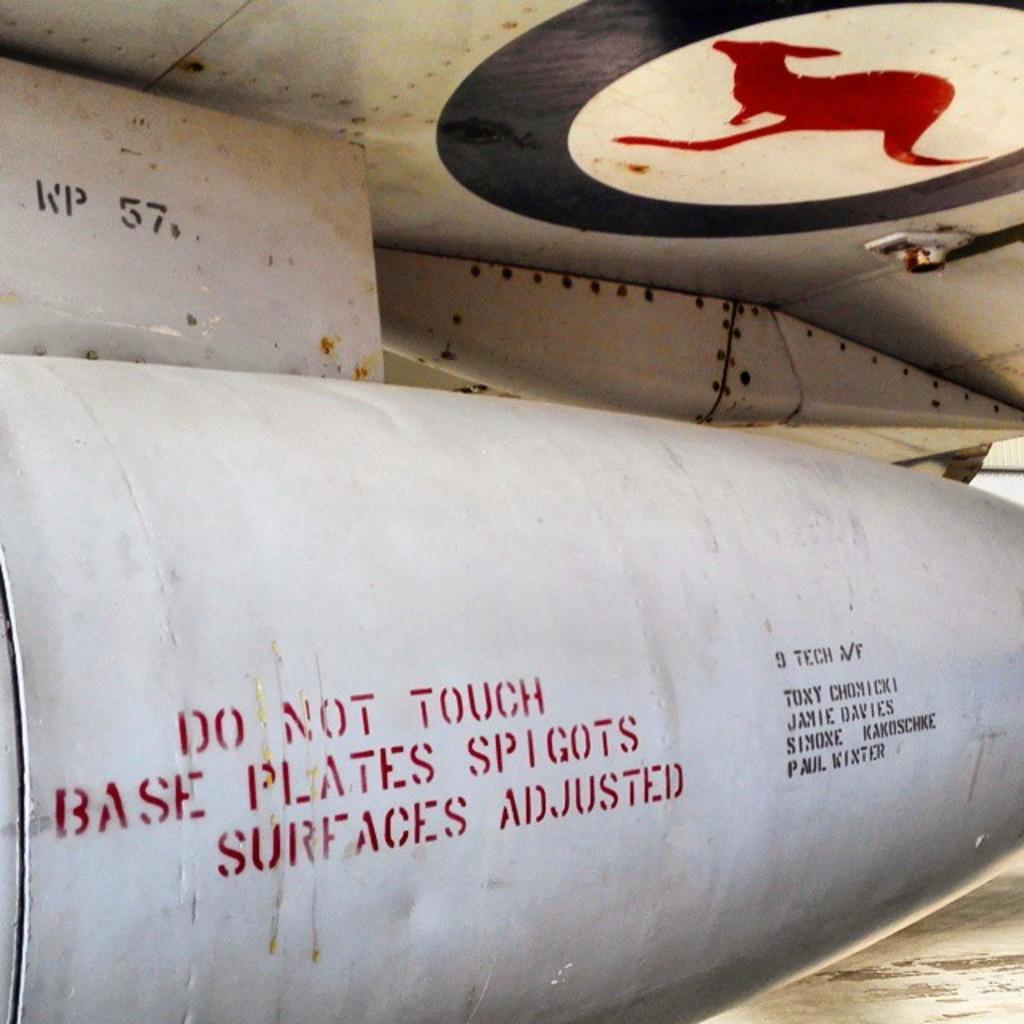Provide a one-sentence caption for the provided image. A large piece of machinery has a warning that says "Do not touch base plates spigots surfaces adjusted.". 